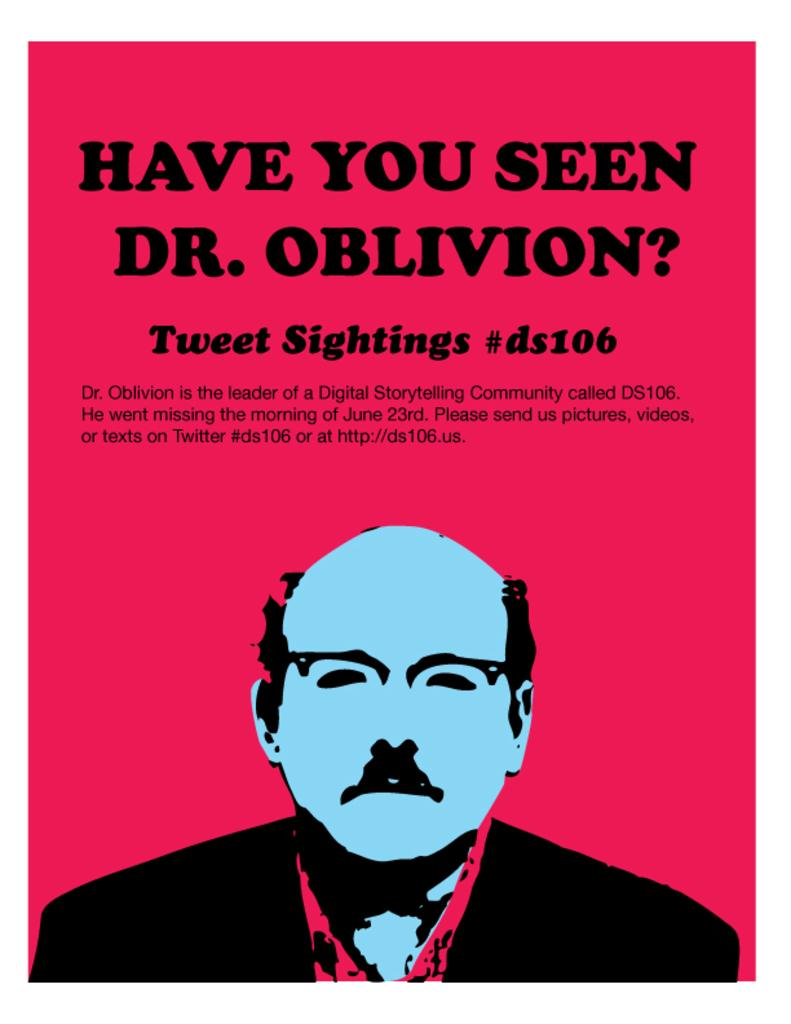<image>
Create a compact narrative representing the image presented. Poster with a man that says"Have You Seen Dr. Oblivion?". 